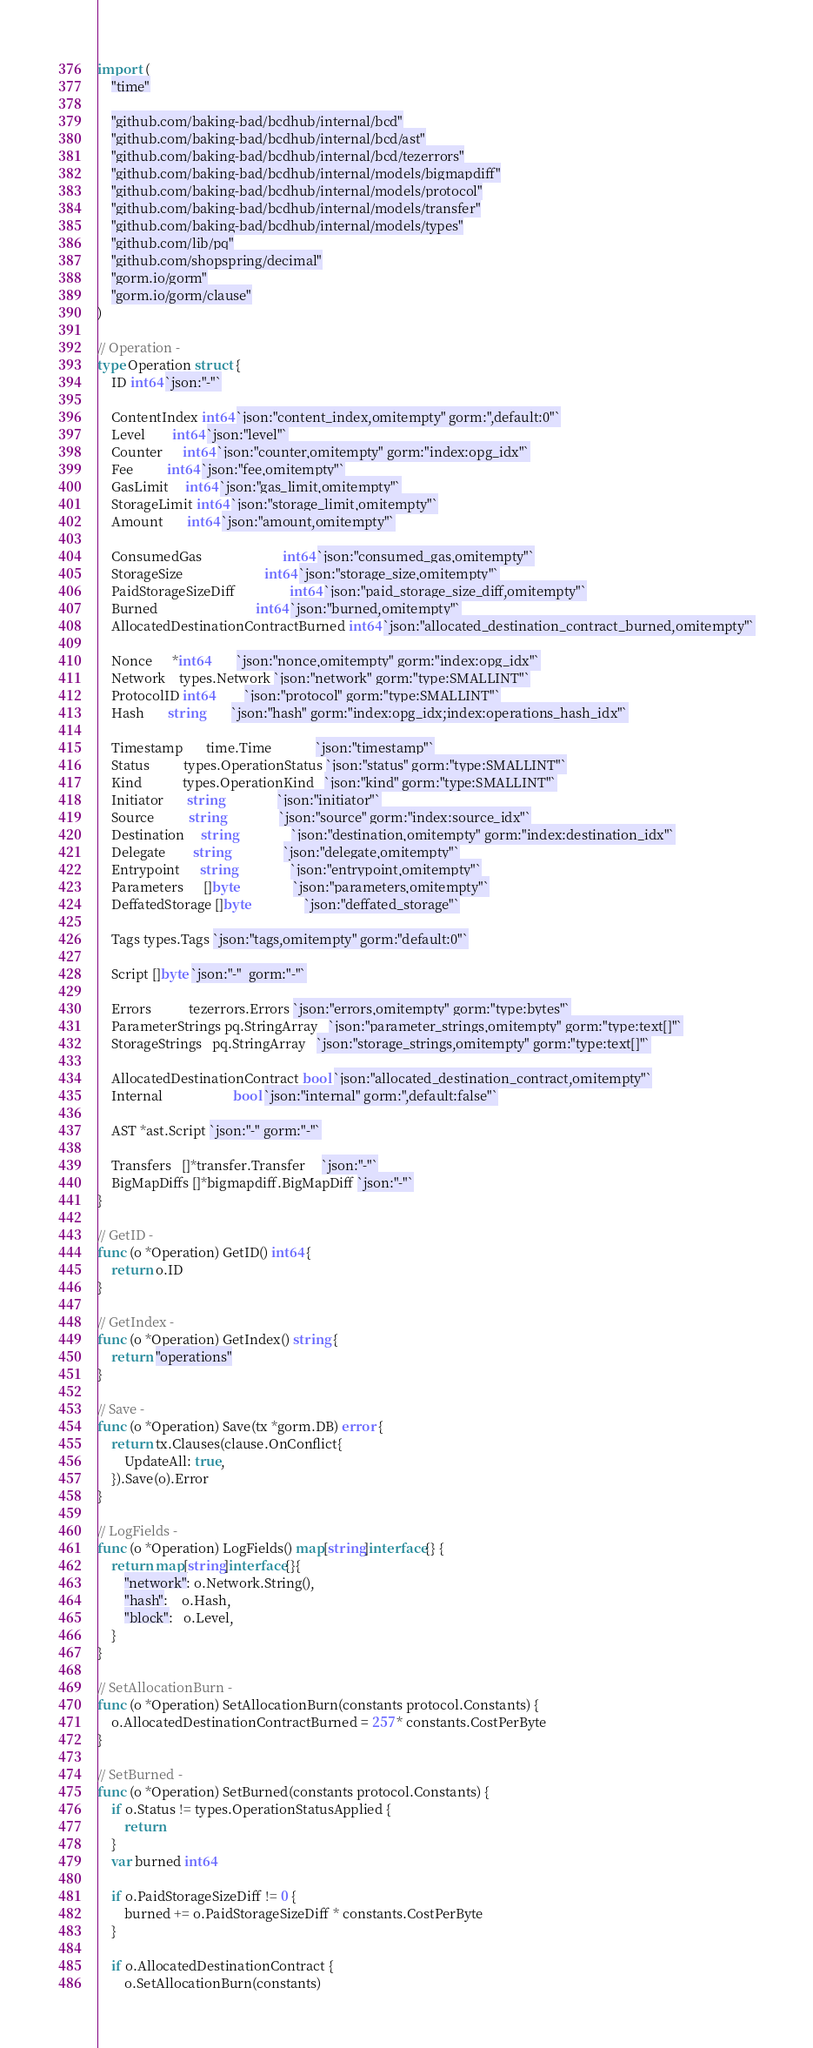Convert code to text. <code><loc_0><loc_0><loc_500><loc_500><_Go_>import (
	"time"

	"github.com/baking-bad/bcdhub/internal/bcd"
	"github.com/baking-bad/bcdhub/internal/bcd/ast"
	"github.com/baking-bad/bcdhub/internal/bcd/tezerrors"
	"github.com/baking-bad/bcdhub/internal/models/bigmapdiff"
	"github.com/baking-bad/bcdhub/internal/models/protocol"
	"github.com/baking-bad/bcdhub/internal/models/transfer"
	"github.com/baking-bad/bcdhub/internal/models/types"
	"github.com/lib/pq"
	"github.com/shopspring/decimal"
	"gorm.io/gorm"
	"gorm.io/gorm/clause"
)

// Operation -
type Operation struct {
	ID int64 `json:"-"`

	ContentIndex int64 `json:"content_index,omitempty" gorm:",default:0"`
	Level        int64 `json:"level"`
	Counter      int64 `json:"counter,omitempty" gorm:"index:opg_idx"`
	Fee          int64 `json:"fee,omitempty"`
	GasLimit     int64 `json:"gas_limit,omitempty"`
	StorageLimit int64 `json:"storage_limit,omitempty"`
	Amount       int64 `json:"amount,omitempty"`

	ConsumedGas                        int64 `json:"consumed_gas,omitempty"`
	StorageSize                        int64 `json:"storage_size,omitempty"`
	PaidStorageSizeDiff                int64 `json:"paid_storage_size_diff,omitempty"`
	Burned                             int64 `json:"burned,omitempty"`
	AllocatedDestinationContractBurned int64 `json:"allocated_destination_contract_burned,omitempty"`

	Nonce      *int64        `json:"nonce,omitempty" gorm:"index:opg_idx"`
	Network    types.Network `json:"network" gorm:"type:SMALLINT"`
	ProtocolID int64         `json:"protocol" gorm:"type:SMALLINT"`
	Hash       string        `json:"hash" gorm:"index:opg_idx;index:operations_hash_idx"`

	Timestamp       time.Time             `json:"timestamp"`
	Status          types.OperationStatus `json:"status" gorm:"type:SMALLINT"`
	Kind            types.OperationKind   `json:"kind" gorm:"type:SMALLINT"`
	Initiator       string                `json:"initiator"`
	Source          string                `json:"source" gorm:"index:source_idx"`
	Destination     string                `json:"destination,omitempty" gorm:"index:destination_idx"`
	Delegate        string                `json:"delegate,omitempty"`
	Entrypoint      string                `json:"entrypoint,omitempty"`
	Parameters      []byte                `json:"parameters,omitempty"`
	DeffatedStorage []byte                `json:"deffated_storage"`

	Tags types.Tags `json:"tags,omitempty" gorm:"default:0"`

	Script []byte `json:"-"  gorm:"-"`

	Errors           tezerrors.Errors `json:"errors,omitempty" gorm:"type:bytes"`
	ParameterStrings pq.StringArray   `json:"parameter_strings,omitempty" gorm:"type:text[]"`
	StorageStrings   pq.StringArray   `json:"storage_strings,omitempty" gorm:"type:text[]"`

	AllocatedDestinationContract bool `json:"allocated_destination_contract,omitempty"`
	Internal                     bool `json:"internal" gorm:",default:false"`

	AST *ast.Script `json:"-" gorm:"-"`

	Transfers   []*transfer.Transfer     `json:"-"`
	BigMapDiffs []*bigmapdiff.BigMapDiff `json:"-"`
}

// GetID -
func (o *Operation) GetID() int64 {
	return o.ID
}

// GetIndex -
func (o *Operation) GetIndex() string {
	return "operations"
}

// Save -
func (o *Operation) Save(tx *gorm.DB) error {
	return tx.Clauses(clause.OnConflict{
		UpdateAll: true,
	}).Save(o).Error
}

// LogFields -
func (o *Operation) LogFields() map[string]interface{} {
	return map[string]interface{}{
		"network": o.Network.String(),
		"hash":    o.Hash,
		"block":   o.Level,
	}
}

// SetAllocationBurn -
func (o *Operation) SetAllocationBurn(constants protocol.Constants) {
	o.AllocatedDestinationContractBurned = 257 * constants.CostPerByte
}

// SetBurned -
func (o *Operation) SetBurned(constants protocol.Constants) {
	if o.Status != types.OperationStatusApplied {
		return
	}
	var burned int64

	if o.PaidStorageSizeDiff != 0 {
		burned += o.PaidStorageSizeDiff * constants.CostPerByte
	}

	if o.AllocatedDestinationContract {
		o.SetAllocationBurn(constants)</code> 